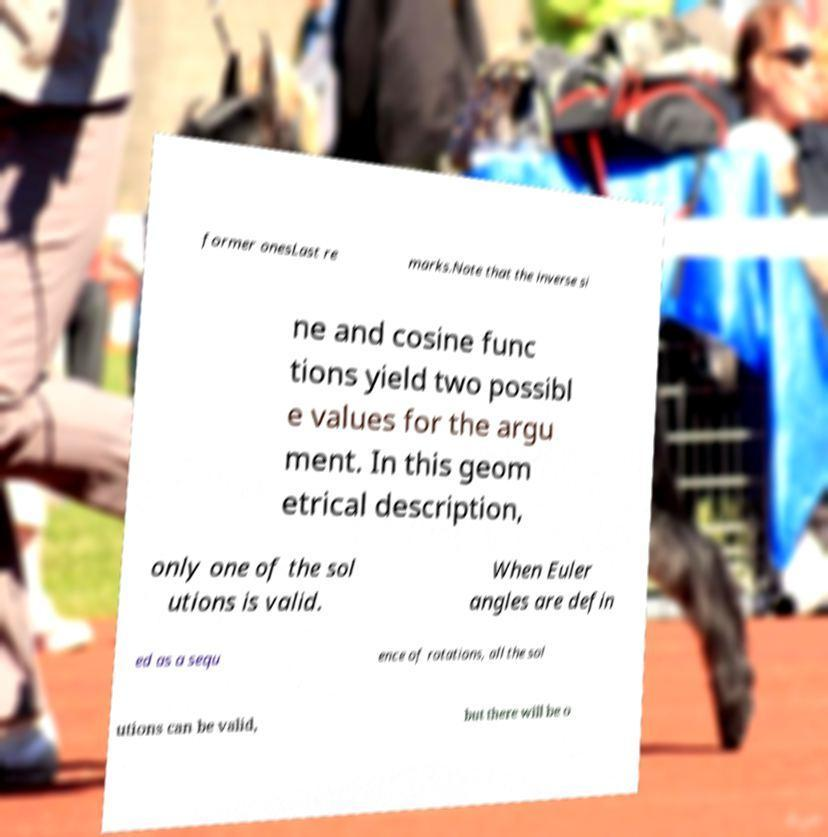Please read and relay the text visible in this image. What does it say? former onesLast re marks.Note that the inverse si ne and cosine func tions yield two possibl e values for the argu ment. In this geom etrical description, only one of the sol utions is valid. When Euler angles are defin ed as a sequ ence of rotations, all the sol utions can be valid, but there will be o 